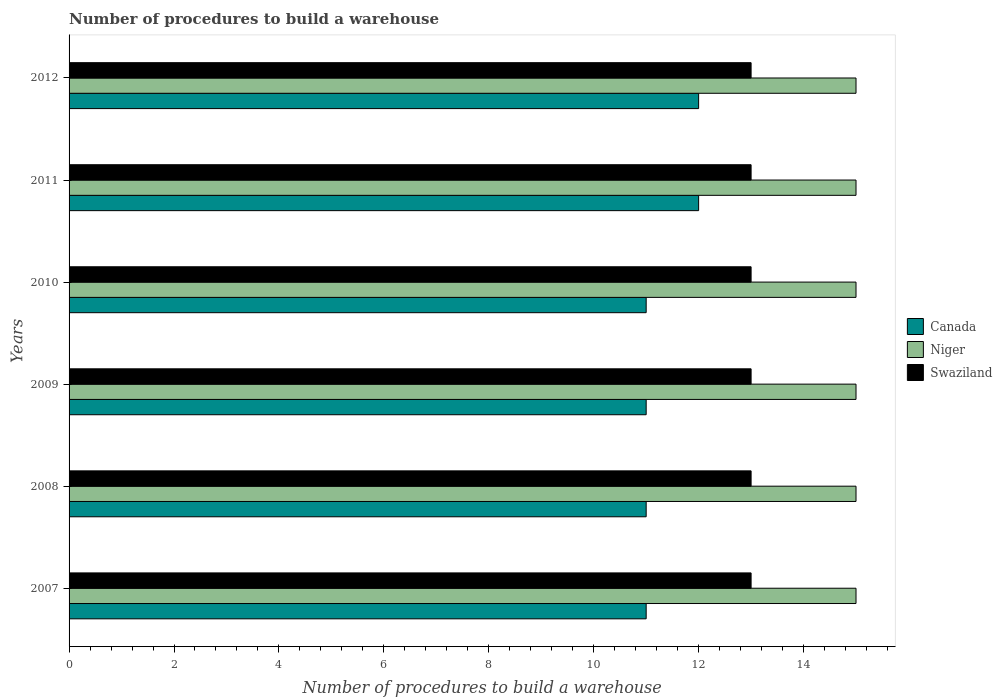How many groups of bars are there?
Your answer should be compact. 6. Are the number of bars on each tick of the Y-axis equal?
Your answer should be very brief. Yes. In how many cases, is the number of bars for a given year not equal to the number of legend labels?
Your answer should be compact. 0. What is the number of procedures to build a warehouse in in Niger in 2010?
Offer a terse response. 15. Across all years, what is the maximum number of procedures to build a warehouse in in Canada?
Make the answer very short. 12. Across all years, what is the minimum number of procedures to build a warehouse in in Swaziland?
Provide a succinct answer. 13. What is the total number of procedures to build a warehouse in in Niger in the graph?
Provide a succinct answer. 90. What is the difference between the number of procedures to build a warehouse in in Canada in 2009 and that in 2011?
Provide a succinct answer. -1. What is the difference between the number of procedures to build a warehouse in in Niger in 2010 and the number of procedures to build a warehouse in in Swaziland in 2008?
Your response must be concise. 2. In the year 2007, what is the difference between the number of procedures to build a warehouse in in Niger and number of procedures to build a warehouse in in Canada?
Offer a terse response. 4. In how many years, is the number of procedures to build a warehouse in in Swaziland greater than 1.6 ?
Offer a terse response. 6. What is the ratio of the number of procedures to build a warehouse in in Swaziland in 2009 to that in 2012?
Provide a short and direct response. 1. Is the difference between the number of procedures to build a warehouse in in Niger in 2008 and 2011 greater than the difference between the number of procedures to build a warehouse in in Canada in 2008 and 2011?
Make the answer very short. Yes. What is the difference between the highest and the second highest number of procedures to build a warehouse in in Niger?
Provide a short and direct response. 0. What is the difference between the highest and the lowest number of procedures to build a warehouse in in Niger?
Your response must be concise. 0. In how many years, is the number of procedures to build a warehouse in in Canada greater than the average number of procedures to build a warehouse in in Canada taken over all years?
Make the answer very short. 2. What does the 2nd bar from the top in 2010 represents?
Keep it short and to the point. Niger. Is it the case that in every year, the sum of the number of procedures to build a warehouse in in Niger and number of procedures to build a warehouse in in Canada is greater than the number of procedures to build a warehouse in in Swaziland?
Your answer should be very brief. Yes. How many bars are there?
Your answer should be compact. 18. Are all the bars in the graph horizontal?
Keep it short and to the point. Yes. What is the difference between two consecutive major ticks on the X-axis?
Keep it short and to the point. 2. Are the values on the major ticks of X-axis written in scientific E-notation?
Offer a terse response. No. Does the graph contain grids?
Provide a succinct answer. No. Where does the legend appear in the graph?
Offer a terse response. Center right. How are the legend labels stacked?
Make the answer very short. Vertical. What is the title of the graph?
Offer a terse response. Number of procedures to build a warehouse. What is the label or title of the X-axis?
Your answer should be very brief. Number of procedures to build a warehouse. What is the Number of procedures to build a warehouse in Canada in 2007?
Make the answer very short. 11. What is the Number of procedures to build a warehouse of Niger in 2007?
Make the answer very short. 15. What is the Number of procedures to build a warehouse of Canada in 2008?
Offer a very short reply. 11. What is the Number of procedures to build a warehouse in Niger in 2008?
Provide a succinct answer. 15. What is the Number of procedures to build a warehouse of Swaziland in 2008?
Keep it short and to the point. 13. What is the Number of procedures to build a warehouse in Canada in 2009?
Offer a very short reply. 11. What is the Number of procedures to build a warehouse of Swaziland in 2009?
Give a very brief answer. 13. What is the Number of procedures to build a warehouse of Niger in 2010?
Offer a terse response. 15. What is the Number of procedures to build a warehouse of Canada in 2011?
Offer a very short reply. 12. What is the Number of procedures to build a warehouse of Niger in 2011?
Your answer should be very brief. 15. What is the Number of procedures to build a warehouse of Swaziland in 2011?
Make the answer very short. 13. What is the Number of procedures to build a warehouse of Canada in 2012?
Your answer should be very brief. 12. What is the Number of procedures to build a warehouse in Niger in 2012?
Provide a short and direct response. 15. What is the Number of procedures to build a warehouse of Swaziland in 2012?
Keep it short and to the point. 13. Across all years, what is the maximum Number of procedures to build a warehouse in Canada?
Give a very brief answer. 12. Across all years, what is the minimum Number of procedures to build a warehouse of Niger?
Ensure brevity in your answer.  15. What is the total Number of procedures to build a warehouse in Canada in the graph?
Your answer should be compact. 68. What is the total Number of procedures to build a warehouse of Niger in the graph?
Make the answer very short. 90. What is the difference between the Number of procedures to build a warehouse in Canada in 2007 and that in 2008?
Make the answer very short. 0. What is the difference between the Number of procedures to build a warehouse in Niger in 2007 and that in 2008?
Provide a short and direct response. 0. What is the difference between the Number of procedures to build a warehouse in Swaziland in 2007 and that in 2008?
Make the answer very short. 0. What is the difference between the Number of procedures to build a warehouse of Canada in 2007 and that in 2009?
Offer a terse response. 0. What is the difference between the Number of procedures to build a warehouse in Niger in 2007 and that in 2009?
Make the answer very short. 0. What is the difference between the Number of procedures to build a warehouse in Canada in 2007 and that in 2010?
Your answer should be compact. 0. What is the difference between the Number of procedures to build a warehouse of Canada in 2007 and that in 2011?
Your answer should be compact. -1. What is the difference between the Number of procedures to build a warehouse in Niger in 2007 and that in 2011?
Keep it short and to the point. 0. What is the difference between the Number of procedures to build a warehouse of Canada in 2008 and that in 2009?
Ensure brevity in your answer.  0. What is the difference between the Number of procedures to build a warehouse of Niger in 2008 and that in 2009?
Provide a succinct answer. 0. What is the difference between the Number of procedures to build a warehouse in Canada in 2008 and that in 2010?
Offer a terse response. 0. What is the difference between the Number of procedures to build a warehouse in Niger in 2008 and that in 2010?
Offer a terse response. 0. What is the difference between the Number of procedures to build a warehouse of Canada in 2008 and that in 2012?
Keep it short and to the point. -1. What is the difference between the Number of procedures to build a warehouse of Swaziland in 2008 and that in 2012?
Ensure brevity in your answer.  0. What is the difference between the Number of procedures to build a warehouse in Canada in 2009 and that in 2010?
Your answer should be compact. 0. What is the difference between the Number of procedures to build a warehouse of Swaziland in 2009 and that in 2010?
Ensure brevity in your answer.  0. What is the difference between the Number of procedures to build a warehouse of Canada in 2009 and that in 2011?
Provide a short and direct response. -1. What is the difference between the Number of procedures to build a warehouse in Canada in 2009 and that in 2012?
Offer a very short reply. -1. What is the difference between the Number of procedures to build a warehouse of Niger in 2009 and that in 2012?
Your answer should be very brief. 0. What is the difference between the Number of procedures to build a warehouse in Canada in 2010 and that in 2011?
Offer a very short reply. -1. What is the difference between the Number of procedures to build a warehouse of Niger in 2010 and that in 2011?
Give a very brief answer. 0. What is the difference between the Number of procedures to build a warehouse of Canada in 2010 and that in 2012?
Ensure brevity in your answer.  -1. What is the difference between the Number of procedures to build a warehouse in Swaziland in 2010 and that in 2012?
Give a very brief answer. 0. What is the difference between the Number of procedures to build a warehouse in Canada in 2011 and that in 2012?
Offer a very short reply. 0. What is the difference between the Number of procedures to build a warehouse in Niger in 2011 and that in 2012?
Your answer should be compact. 0. What is the difference between the Number of procedures to build a warehouse of Canada in 2007 and the Number of procedures to build a warehouse of Swaziland in 2008?
Your answer should be very brief. -2. What is the difference between the Number of procedures to build a warehouse of Canada in 2007 and the Number of procedures to build a warehouse of Niger in 2009?
Your answer should be very brief. -4. What is the difference between the Number of procedures to build a warehouse in Canada in 2007 and the Number of procedures to build a warehouse in Swaziland in 2010?
Provide a succinct answer. -2. What is the difference between the Number of procedures to build a warehouse in Niger in 2007 and the Number of procedures to build a warehouse in Swaziland in 2010?
Ensure brevity in your answer.  2. What is the difference between the Number of procedures to build a warehouse of Canada in 2007 and the Number of procedures to build a warehouse of Niger in 2011?
Offer a terse response. -4. What is the difference between the Number of procedures to build a warehouse of Niger in 2007 and the Number of procedures to build a warehouse of Swaziland in 2011?
Make the answer very short. 2. What is the difference between the Number of procedures to build a warehouse of Niger in 2007 and the Number of procedures to build a warehouse of Swaziland in 2012?
Offer a terse response. 2. What is the difference between the Number of procedures to build a warehouse of Canada in 2008 and the Number of procedures to build a warehouse of Swaziland in 2009?
Give a very brief answer. -2. What is the difference between the Number of procedures to build a warehouse in Niger in 2008 and the Number of procedures to build a warehouse in Swaziland in 2009?
Your response must be concise. 2. What is the difference between the Number of procedures to build a warehouse in Niger in 2008 and the Number of procedures to build a warehouse in Swaziland in 2010?
Your answer should be very brief. 2. What is the difference between the Number of procedures to build a warehouse of Canada in 2008 and the Number of procedures to build a warehouse of Niger in 2011?
Keep it short and to the point. -4. What is the difference between the Number of procedures to build a warehouse of Niger in 2008 and the Number of procedures to build a warehouse of Swaziland in 2011?
Offer a very short reply. 2. What is the difference between the Number of procedures to build a warehouse in Canada in 2008 and the Number of procedures to build a warehouse in Swaziland in 2012?
Keep it short and to the point. -2. What is the difference between the Number of procedures to build a warehouse in Niger in 2008 and the Number of procedures to build a warehouse in Swaziland in 2012?
Provide a succinct answer. 2. What is the difference between the Number of procedures to build a warehouse in Niger in 2009 and the Number of procedures to build a warehouse in Swaziland in 2010?
Provide a short and direct response. 2. What is the difference between the Number of procedures to build a warehouse of Canada in 2009 and the Number of procedures to build a warehouse of Niger in 2011?
Your response must be concise. -4. What is the difference between the Number of procedures to build a warehouse in Canada in 2009 and the Number of procedures to build a warehouse in Swaziland in 2011?
Provide a succinct answer. -2. What is the difference between the Number of procedures to build a warehouse of Niger in 2009 and the Number of procedures to build a warehouse of Swaziland in 2011?
Provide a succinct answer. 2. What is the difference between the Number of procedures to build a warehouse in Canada in 2009 and the Number of procedures to build a warehouse in Swaziland in 2012?
Offer a very short reply. -2. What is the difference between the Number of procedures to build a warehouse of Niger in 2009 and the Number of procedures to build a warehouse of Swaziland in 2012?
Provide a short and direct response. 2. What is the difference between the Number of procedures to build a warehouse of Canada in 2010 and the Number of procedures to build a warehouse of Niger in 2011?
Provide a short and direct response. -4. What is the difference between the Number of procedures to build a warehouse of Canada in 2010 and the Number of procedures to build a warehouse of Swaziland in 2011?
Make the answer very short. -2. What is the difference between the Number of procedures to build a warehouse of Niger in 2010 and the Number of procedures to build a warehouse of Swaziland in 2011?
Provide a short and direct response. 2. What is the difference between the Number of procedures to build a warehouse of Canada in 2010 and the Number of procedures to build a warehouse of Niger in 2012?
Your answer should be compact. -4. What is the difference between the Number of procedures to build a warehouse in Canada in 2010 and the Number of procedures to build a warehouse in Swaziland in 2012?
Keep it short and to the point. -2. What is the difference between the Number of procedures to build a warehouse of Canada in 2011 and the Number of procedures to build a warehouse of Niger in 2012?
Make the answer very short. -3. What is the difference between the Number of procedures to build a warehouse in Niger in 2011 and the Number of procedures to build a warehouse in Swaziland in 2012?
Offer a very short reply. 2. What is the average Number of procedures to build a warehouse of Canada per year?
Offer a terse response. 11.33. What is the average Number of procedures to build a warehouse in Swaziland per year?
Make the answer very short. 13. In the year 2007, what is the difference between the Number of procedures to build a warehouse of Canada and Number of procedures to build a warehouse of Niger?
Give a very brief answer. -4. In the year 2007, what is the difference between the Number of procedures to build a warehouse in Canada and Number of procedures to build a warehouse in Swaziland?
Your answer should be compact. -2. In the year 2007, what is the difference between the Number of procedures to build a warehouse of Niger and Number of procedures to build a warehouse of Swaziland?
Provide a succinct answer. 2. In the year 2008, what is the difference between the Number of procedures to build a warehouse of Canada and Number of procedures to build a warehouse of Niger?
Offer a very short reply. -4. In the year 2009, what is the difference between the Number of procedures to build a warehouse of Niger and Number of procedures to build a warehouse of Swaziland?
Ensure brevity in your answer.  2. In the year 2010, what is the difference between the Number of procedures to build a warehouse in Canada and Number of procedures to build a warehouse in Niger?
Give a very brief answer. -4. In the year 2010, what is the difference between the Number of procedures to build a warehouse of Niger and Number of procedures to build a warehouse of Swaziland?
Your answer should be compact. 2. In the year 2011, what is the difference between the Number of procedures to build a warehouse in Canada and Number of procedures to build a warehouse in Swaziland?
Your answer should be very brief. -1. In the year 2011, what is the difference between the Number of procedures to build a warehouse of Niger and Number of procedures to build a warehouse of Swaziland?
Make the answer very short. 2. In the year 2012, what is the difference between the Number of procedures to build a warehouse in Canada and Number of procedures to build a warehouse in Swaziland?
Make the answer very short. -1. In the year 2012, what is the difference between the Number of procedures to build a warehouse in Niger and Number of procedures to build a warehouse in Swaziland?
Ensure brevity in your answer.  2. What is the ratio of the Number of procedures to build a warehouse in Canada in 2007 to that in 2008?
Offer a very short reply. 1. What is the ratio of the Number of procedures to build a warehouse in Canada in 2007 to that in 2009?
Your answer should be compact. 1. What is the ratio of the Number of procedures to build a warehouse in Niger in 2007 to that in 2009?
Your answer should be very brief. 1. What is the ratio of the Number of procedures to build a warehouse of Canada in 2007 to that in 2010?
Your answer should be very brief. 1. What is the ratio of the Number of procedures to build a warehouse of Swaziland in 2007 to that in 2010?
Offer a terse response. 1. What is the ratio of the Number of procedures to build a warehouse of Canada in 2007 to that in 2011?
Make the answer very short. 0.92. What is the ratio of the Number of procedures to build a warehouse of Swaziland in 2007 to that in 2012?
Give a very brief answer. 1. What is the ratio of the Number of procedures to build a warehouse of Canada in 2008 to that in 2009?
Make the answer very short. 1. What is the ratio of the Number of procedures to build a warehouse of Swaziland in 2008 to that in 2009?
Your answer should be very brief. 1. What is the ratio of the Number of procedures to build a warehouse in Niger in 2008 to that in 2010?
Your answer should be very brief. 1. What is the ratio of the Number of procedures to build a warehouse in Swaziland in 2008 to that in 2010?
Provide a succinct answer. 1. What is the ratio of the Number of procedures to build a warehouse in Canada in 2008 to that in 2011?
Keep it short and to the point. 0.92. What is the ratio of the Number of procedures to build a warehouse in Swaziland in 2008 to that in 2012?
Your answer should be very brief. 1. What is the ratio of the Number of procedures to build a warehouse of Swaziland in 2009 to that in 2010?
Ensure brevity in your answer.  1. What is the ratio of the Number of procedures to build a warehouse in Niger in 2009 to that in 2011?
Offer a terse response. 1. What is the ratio of the Number of procedures to build a warehouse of Swaziland in 2009 to that in 2011?
Keep it short and to the point. 1. What is the ratio of the Number of procedures to build a warehouse in Canada in 2009 to that in 2012?
Give a very brief answer. 0.92. What is the ratio of the Number of procedures to build a warehouse of Swaziland in 2009 to that in 2012?
Offer a very short reply. 1. What is the ratio of the Number of procedures to build a warehouse of Canada in 2010 to that in 2011?
Provide a succinct answer. 0.92. What is the ratio of the Number of procedures to build a warehouse in Canada in 2010 to that in 2012?
Offer a terse response. 0.92. What is the ratio of the Number of procedures to build a warehouse of Canada in 2011 to that in 2012?
Provide a succinct answer. 1. What is the ratio of the Number of procedures to build a warehouse in Niger in 2011 to that in 2012?
Offer a very short reply. 1. What is the ratio of the Number of procedures to build a warehouse of Swaziland in 2011 to that in 2012?
Keep it short and to the point. 1. What is the difference between the highest and the second highest Number of procedures to build a warehouse of Niger?
Offer a terse response. 0. 